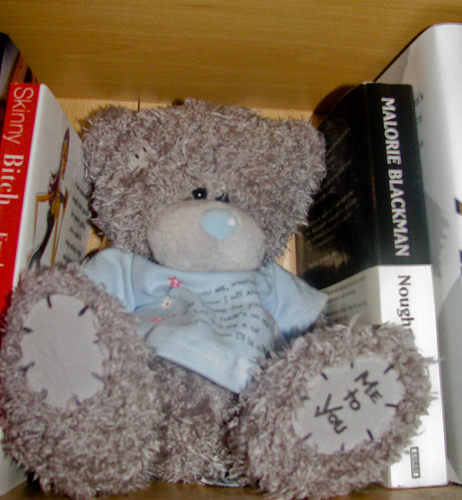<image>
Is there a shirt on the shelf? Yes. Looking at the image, I can see the shirt is positioned on top of the shelf, with the shelf providing support. Is there a bear under the shelf? Yes. The bear is positioned underneath the shelf, with the shelf above it in the vertical space. Is there a bear to the right of the book? No. The bear is not to the right of the book. The horizontal positioning shows a different relationship. 